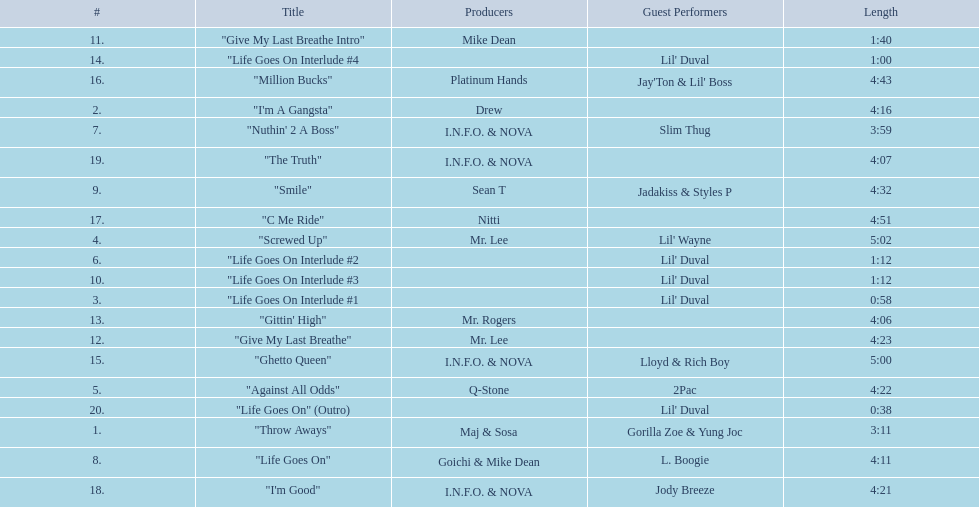What tracks appear on the album life goes on (trae album)? "Throw Aways", "I'm A Gangsta", "Life Goes On Interlude #1, "Screwed Up", "Against All Odds", "Life Goes On Interlude #2, "Nuthin' 2 A Boss", "Life Goes On", "Smile", "Life Goes On Interlude #3, "Give My Last Breathe Intro", "Give My Last Breathe", "Gittin' High", "Life Goes On Interlude #4, "Ghetto Queen", "Million Bucks", "C Me Ride", "I'm Good", "The Truth", "Life Goes On" (Outro). Which of these songs are at least 5 minutes long? "Screwed Up", "Ghetto Queen". Of these two songs over 5 minutes long, which is longer? "Screwed Up". How long is this track? 5:02. 